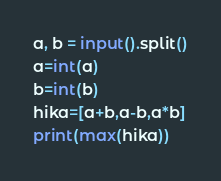Convert code to text. <code><loc_0><loc_0><loc_500><loc_500><_Python_>a, b = input().split()
a=int(a)
b=int(b)
hika=[a+b,a-b,a*b]
print(max(hika))</code> 